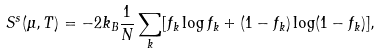<formula> <loc_0><loc_0><loc_500><loc_500>S ^ { s } ( \mu , T ) = - 2 k _ { B } \frac { 1 } { N } \sum _ { k } [ f _ { k } \log f _ { k } + ( 1 - f _ { k } ) \log ( 1 - f _ { k } ) ] ,</formula> 